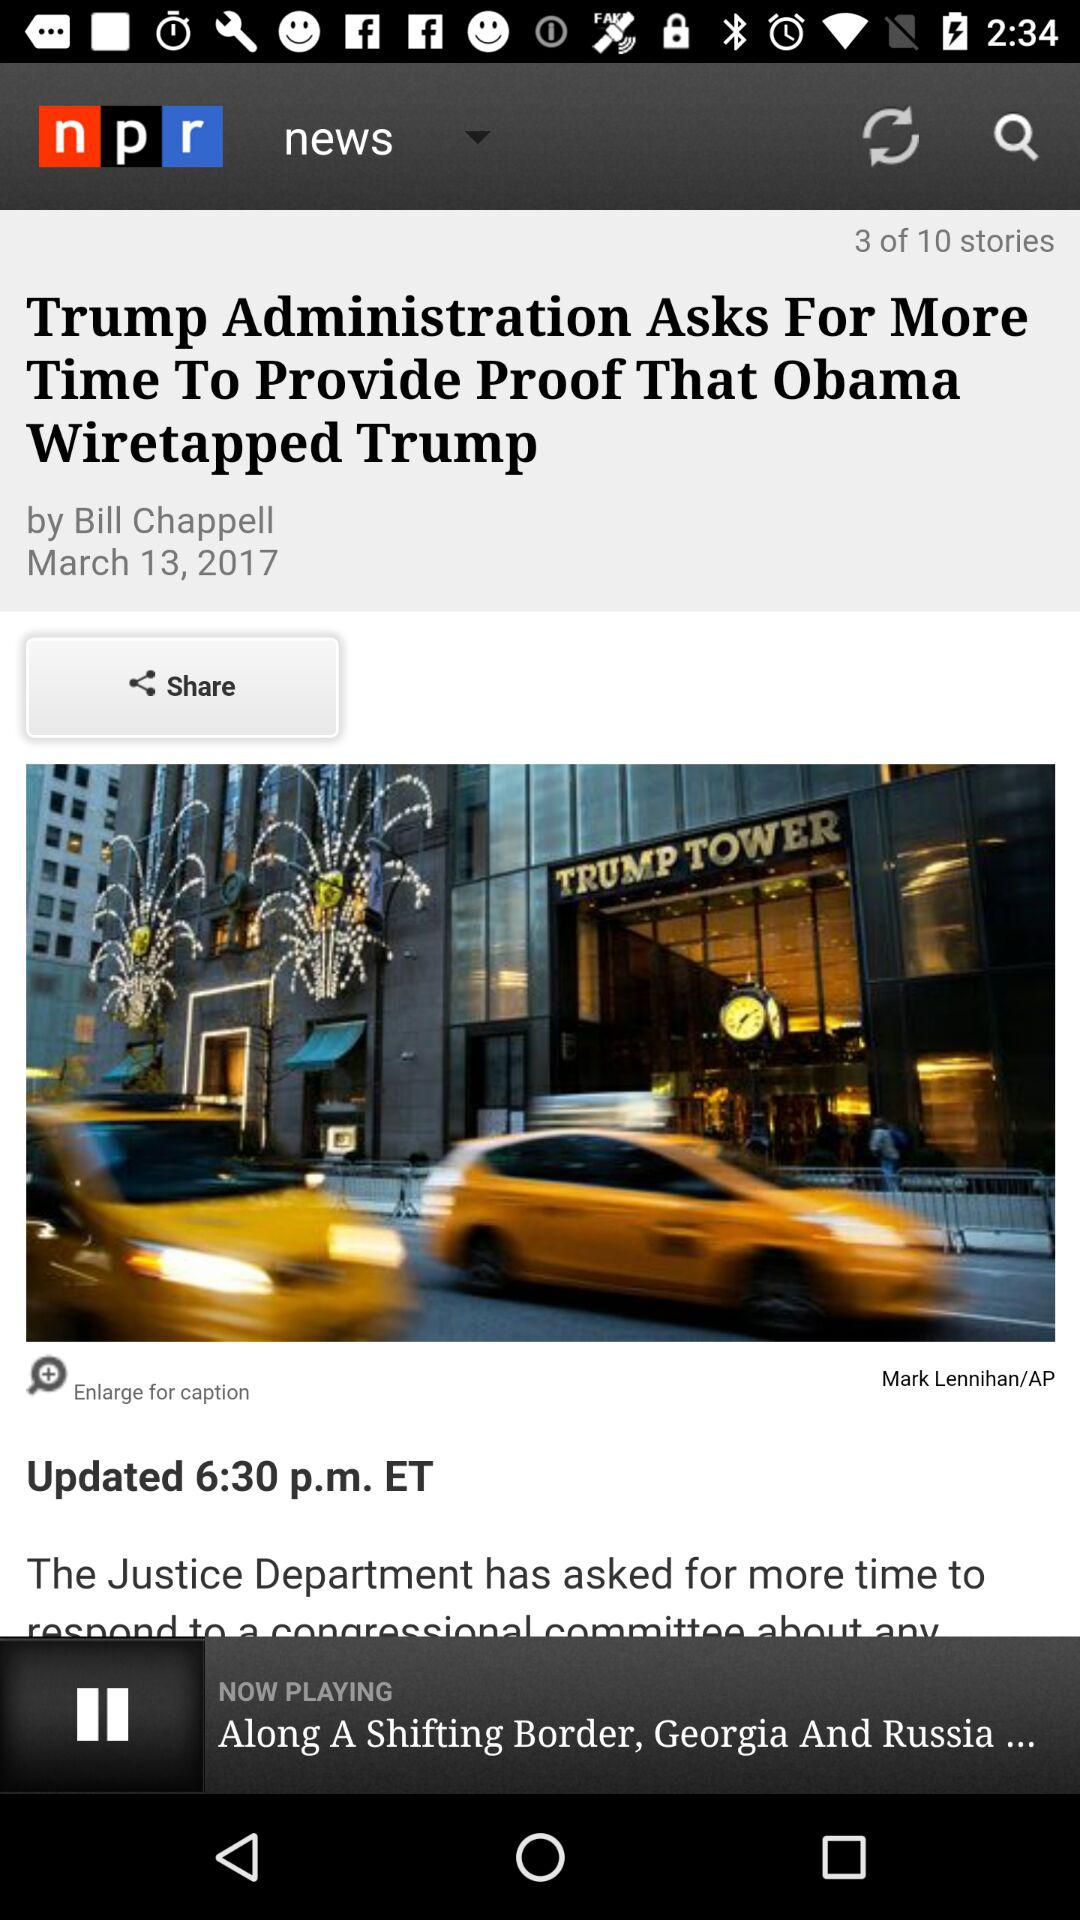Who wrote this article? This article was written by Bill Chappell. 